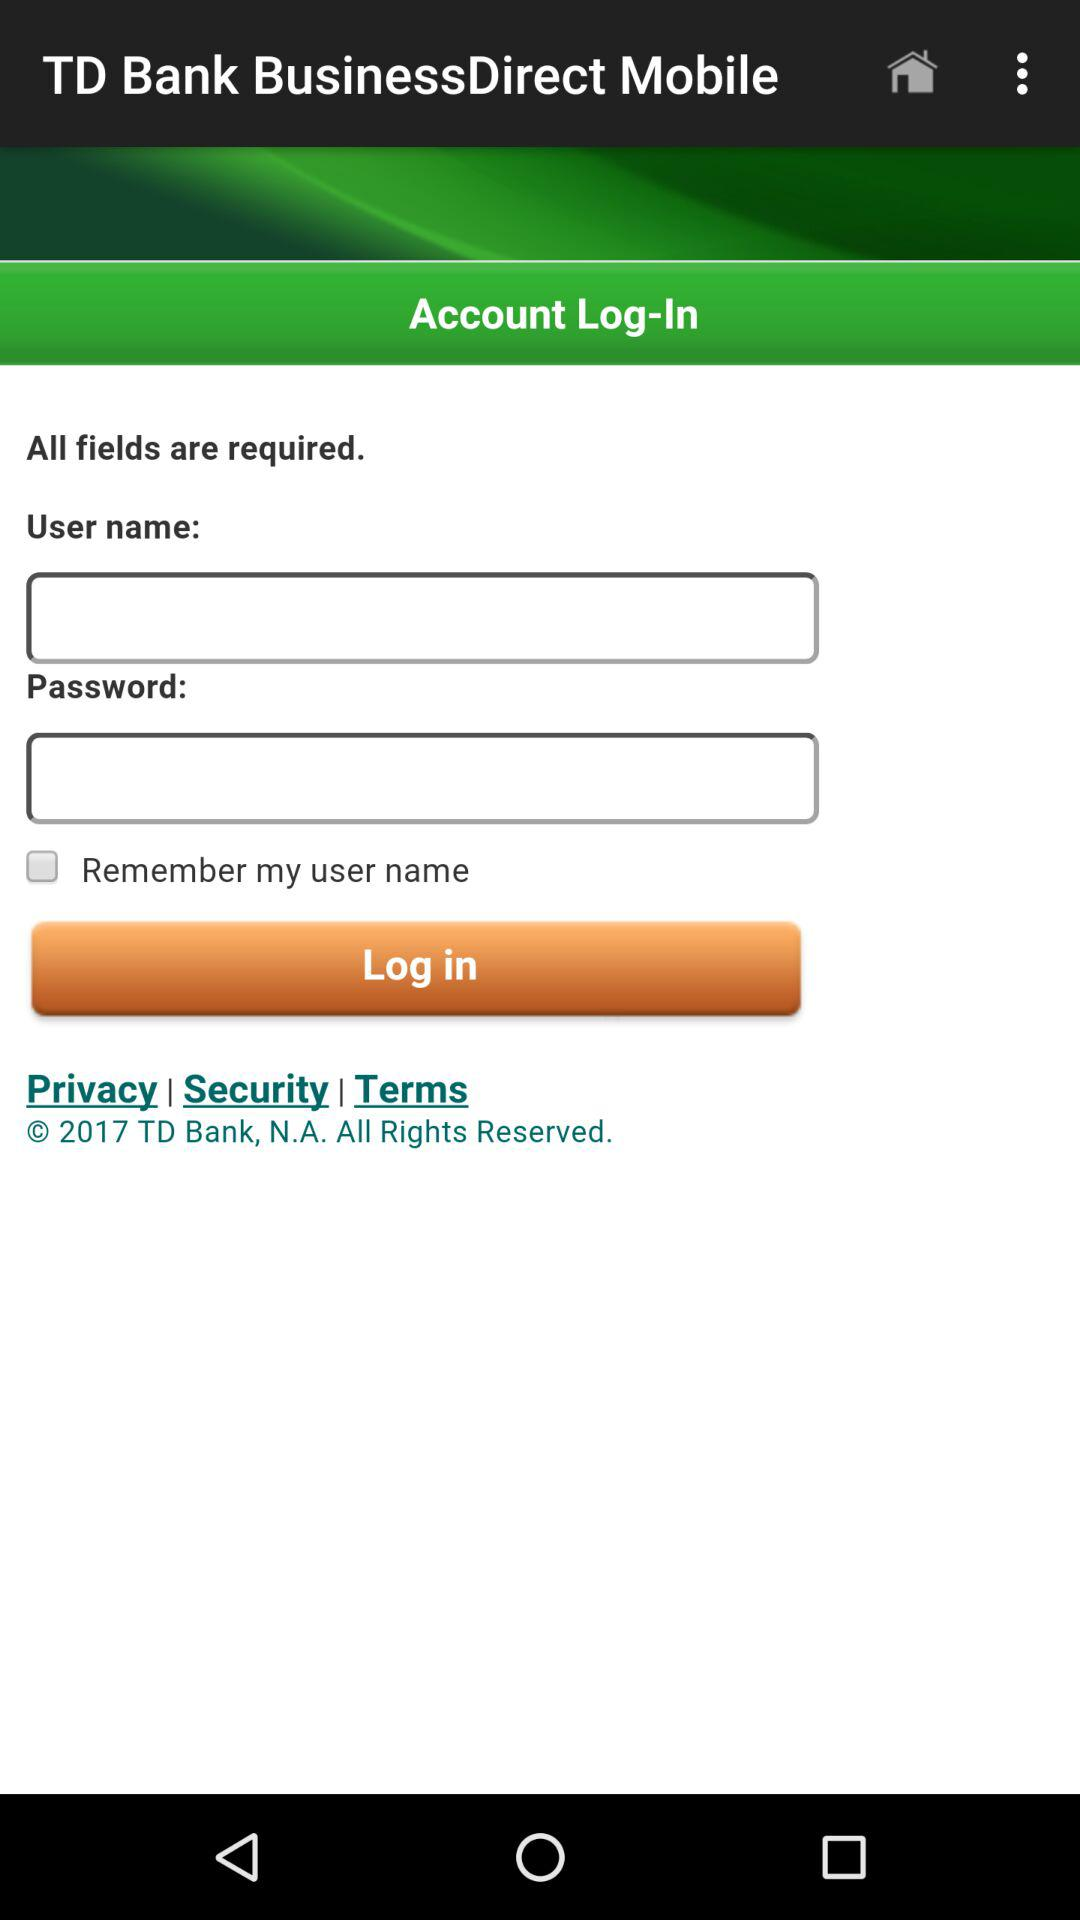What is the application name? The application name is "TD Bank BusinessDirect Mobile". 